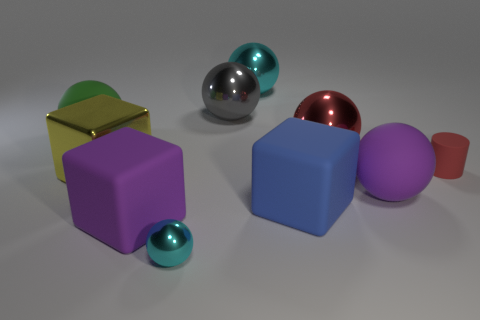Subtract all blue blocks. How many cyan spheres are left? 2 Subtract 4 balls. How many balls are left? 2 Subtract all big rubber balls. How many balls are left? 4 Subtract all cyan balls. How many balls are left? 4 Subtract all blue balls. Subtract all purple cylinders. How many balls are left? 6 Subtract all cylinders. How many objects are left? 9 Add 5 gray things. How many gray things exist? 6 Subtract 1 green balls. How many objects are left? 9 Subtract all brown blocks. Subtract all purple blocks. How many objects are left? 9 Add 2 tiny metallic things. How many tiny metallic things are left? 3 